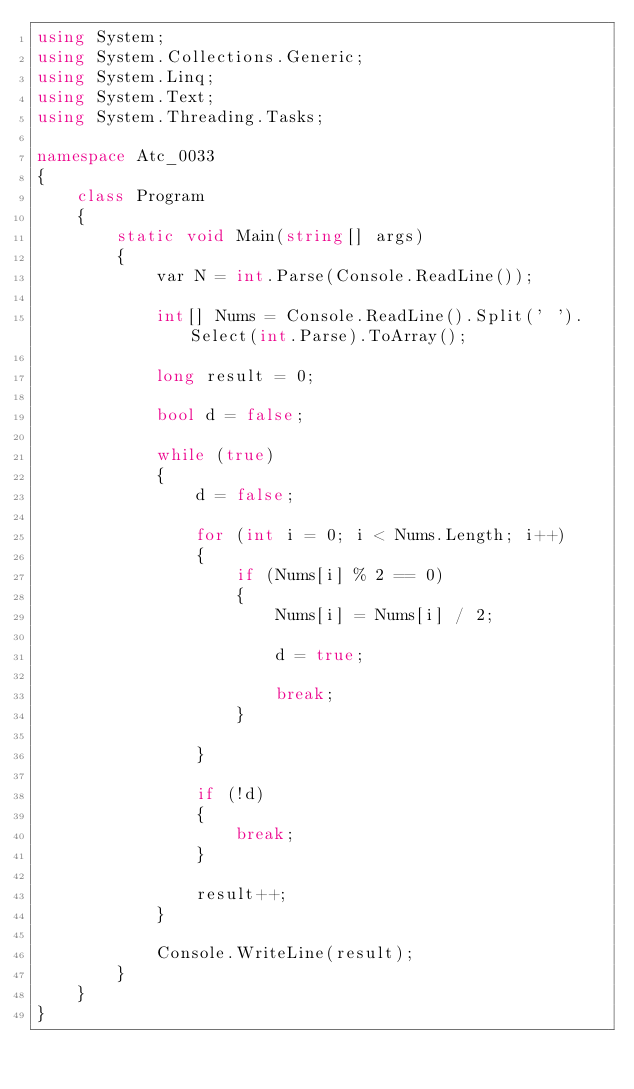Convert code to text. <code><loc_0><loc_0><loc_500><loc_500><_C#_>using System;
using System.Collections.Generic;
using System.Linq;
using System.Text;
using System.Threading.Tasks;

namespace Atc_0033
{
    class Program
    {
        static void Main(string[] args)
        {
            var N = int.Parse(Console.ReadLine());

            int[] Nums = Console.ReadLine().Split(' ').Select(int.Parse).ToArray();

            long result = 0;

            bool d = false;

            while (true)
            {
                d = false;

                for (int i = 0; i < Nums.Length; i++)
                {
                    if (Nums[i] % 2 == 0)
                    {
                        Nums[i] = Nums[i] / 2;

                        d = true;

                        break;
                    }

                }

                if (!d)
                {
                    break;
                }

                result++;
            }

            Console.WriteLine(result);
        }
    }
}
</code> 